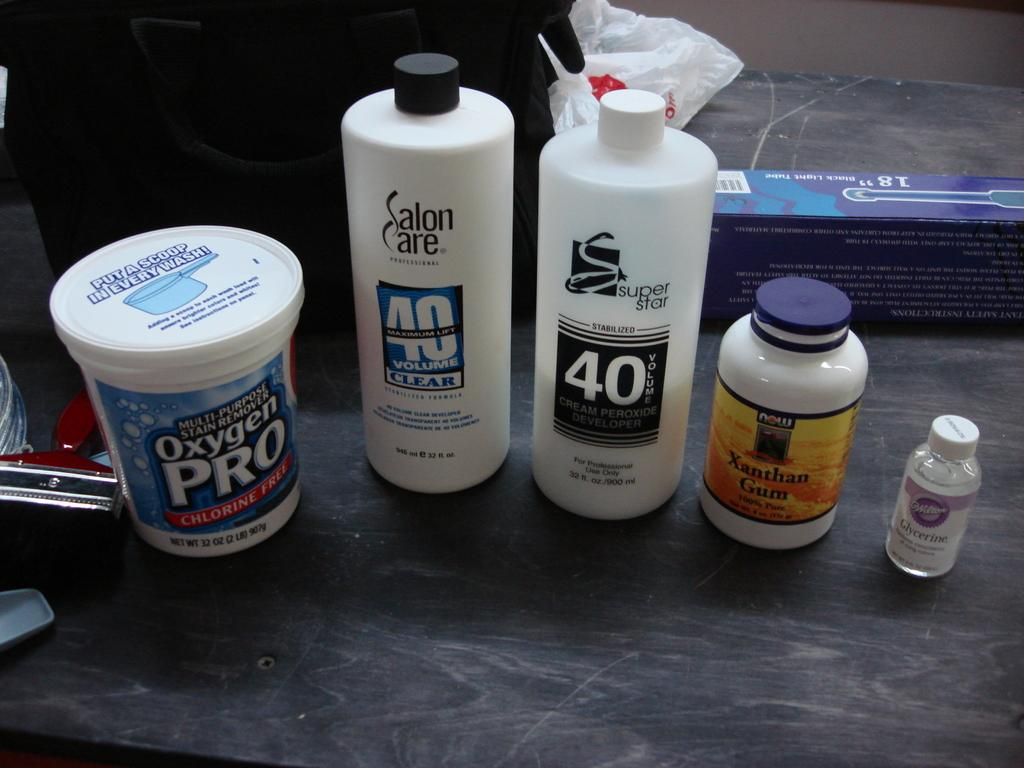<image>
Give a short and clear explanation of the subsequent image. A container of Oxygen Pro sits on a counter next to a container of Salan Care, Supert Star, Xanthan Gum, and Glycerine. 